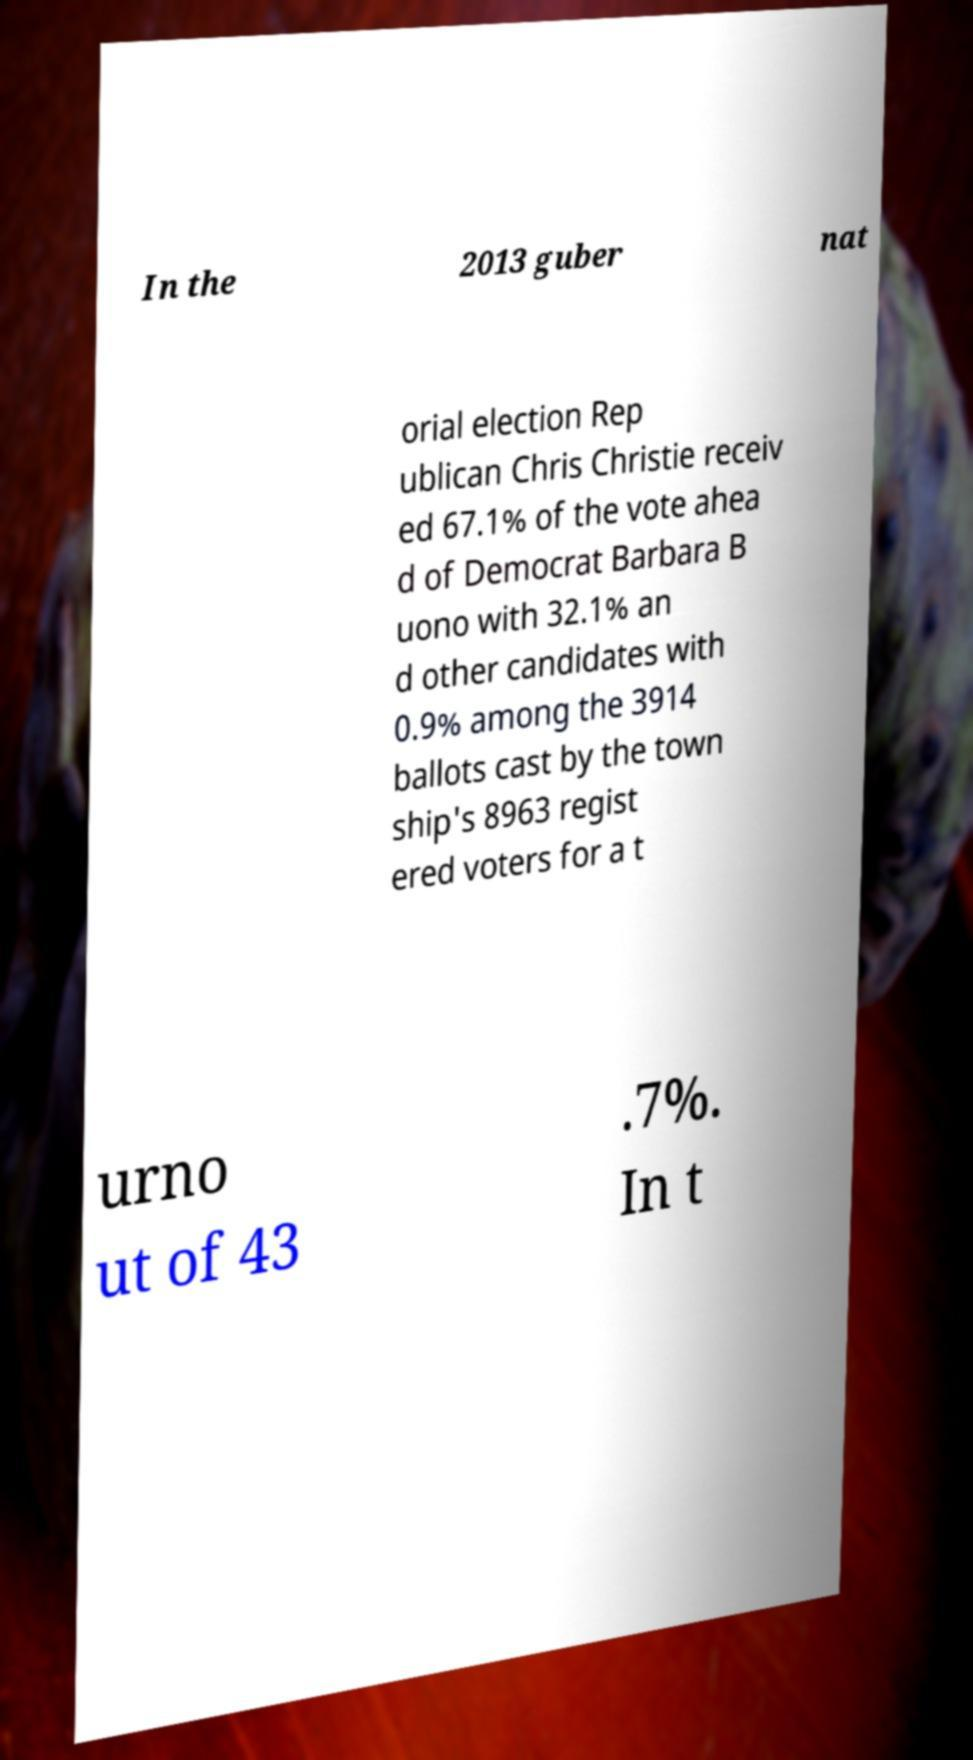For documentation purposes, I need the text within this image transcribed. Could you provide that? In the 2013 guber nat orial election Rep ublican Chris Christie receiv ed 67.1% of the vote ahea d of Democrat Barbara B uono with 32.1% an d other candidates with 0.9% among the 3914 ballots cast by the town ship's 8963 regist ered voters for a t urno ut of 43 .7%. In t 